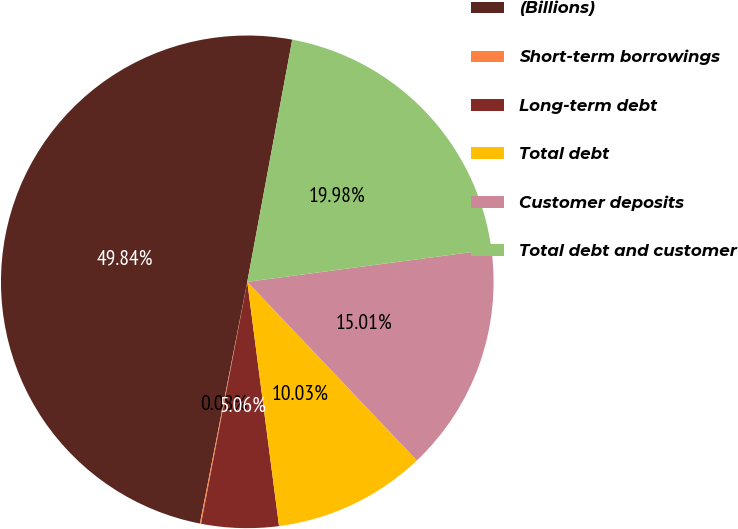<chart> <loc_0><loc_0><loc_500><loc_500><pie_chart><fcel>(Billions)<fcel>Short-term borrowings<fcel>Long-term debt<fcel>Total debt<fcel>Customer deposits<fcel>Total debt and customer<nl><fcel>49.84%<fcel>0.08%<fcel>5.06%<fcel>10.03%<fcel>15.01%<fcel>19.98%<nl></chart> 